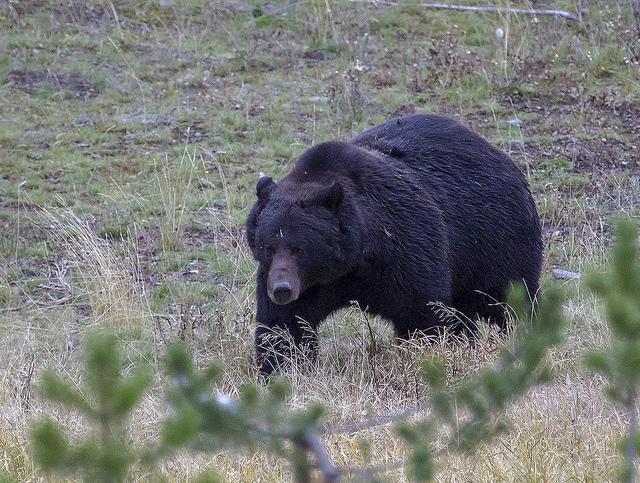How many bears are there?
Give a very brief answer. 1. How many red umbrellas are to the right of the woman in the middle?
Give a very brief answer. 0. 